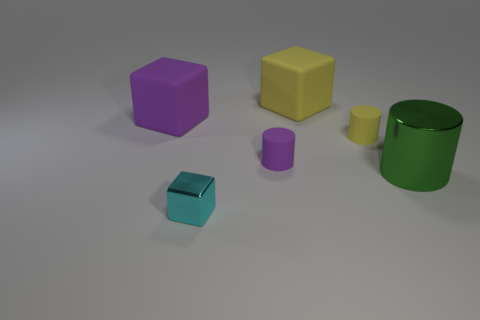There is a large cube that is to the right of the big purple cube; is it the same color as the tiny cylinder on the right side of the small purple matte cylinder?
Give a very brief answer. Yes. The big rubber cube to the left of the small metallic block is what color?
Offer a very short reply. Purple. What is the size of the purple object that is made of the same material as the purple cube?
Give a very brief answer. Small. How many other small rubber things have the same shape as the tiny purple thing?
Offer a terse response. 1. There is another block that is the same size as the purple block; what is its material?
Provide a short and direct response. Rubber. Is there a yellow object that has the same material as the cyan block?
Keep it short and to the point. No. The object that is both to the left of the green cylinder and in front of the purple matte cylinder is what color?
Provide a short and direct response. Cyan. What is the yellow object that is in front of the matte thing behind the rubber cube on the left side of the purple cylinder made of?
Give a very brief answer. Rubber. What number of cubes are big purple matte things or yellow matte things?
Provide a succinct answer. 2. There is a big matte object left of the small cylinder that is to the left of the yellow block; what number of small purple things are to the right of it?
Provide a succinct answer. 1. 